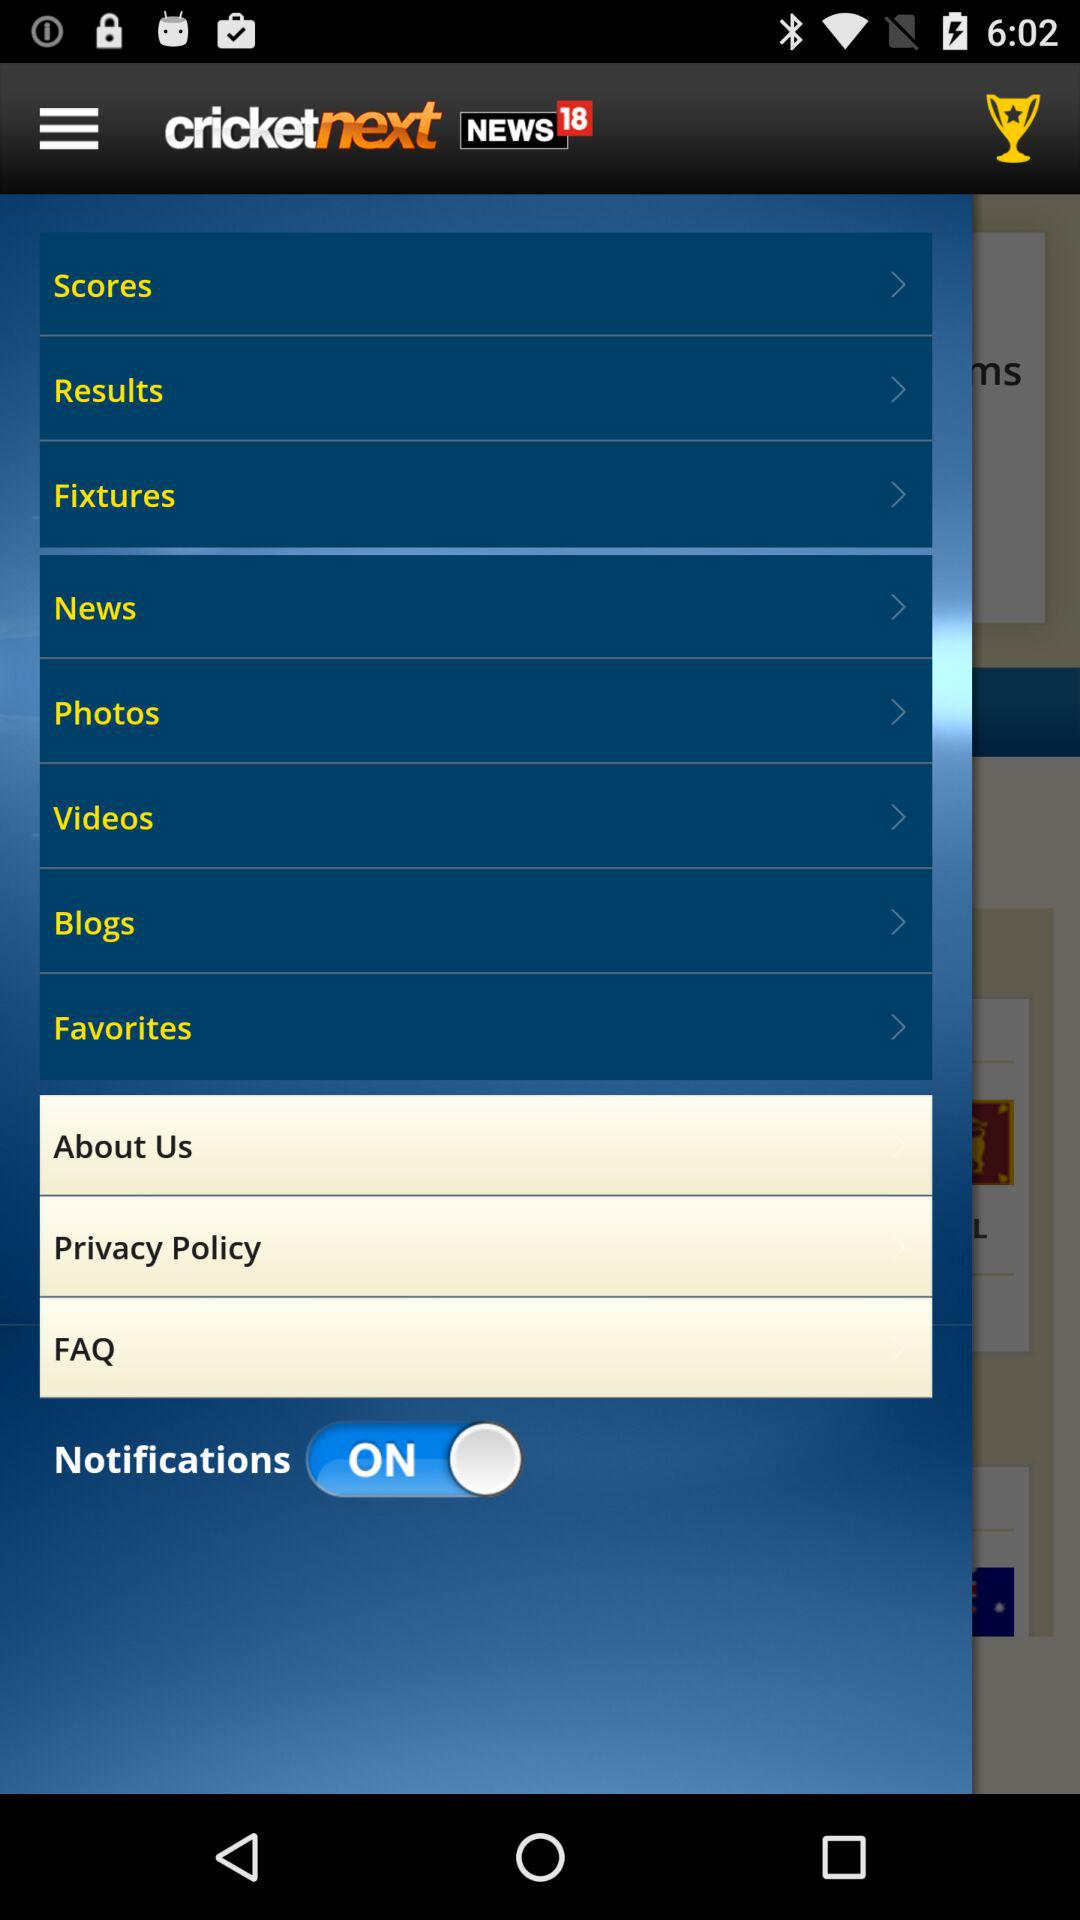What is the name of the application? The name of the application is "cricketnext". 